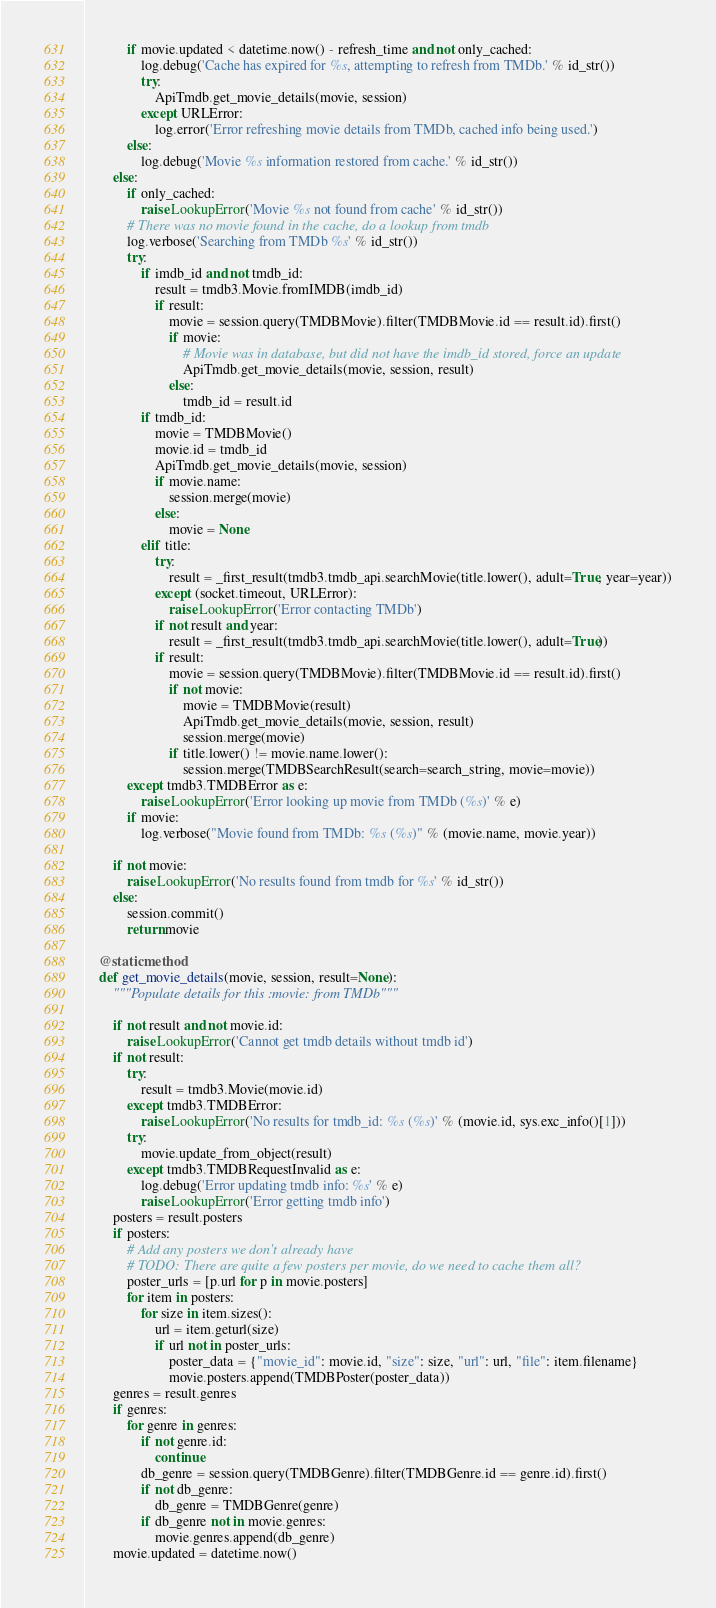<code> <loc_0><loc_0><loc_500><loc_500><_Python_>            if movie.updated < datetime.now() - refresh_time and not only_cached:
                log.debug('Cache has expired for %s, attempting to refresh from TMDb.' % id_str())
                try:
                    ApiTmdb.get_movie_details(movie, session)
                except URLError:
                    log.error('Error refreshing movie details from TMDb, cached info being used.')
            else:
                log.debug('Movie %s information restored from cache.' % id_str())
        else:
            if only_cached:
                raise LookupError('Movie %s not found from cache' % id_str())
            # There was no movie found in the cache, do a lookup from tmdb
            log.verbose('Searching from TMDb %s' % id_str())
            try:
                if imdb_id and not tmdb_id:
                    result = tmdb3.Movie.fromIMDB(imdb_id)
                    if result:
                        movie = session.query(TMDBMovie).filter(TMDBMovie.id == result.id).first()
                        if movie:
                            # Movie was in database, but did not have the imdb_id stored, force an update
                            ApiTmdb.get_movie_details(movie, session, result)
                        else:
                            tmdb_id = result.id
                if tmdb_id:
                    movie = TMDBMovie()
                    movie.id = tmdb_id
                    ApiTmdb.get_movie_details(movie, session)
                    if movie.name:
                        session.merge(movie)
                    else:
                        movie = None
                elif title:
                    try:
                        result = _first_result(tmdb3.tmdb_api.searchMovie(title.lower(), adult=True, year=year))
                    except (socket.timeout, URLError):
                        raise LookupError('Error contacting TMDb')
                    if not result and year:
                        result = _first_result(tmdb3.tmdb_api.searchMovie(title.lower(), adult=True))
                    if result:
                        movie = session.query(TMDBMovie).filter(TMDBMovie.id == result.id).first()
                        if not movie:
                            movie = TMDBMovie(result)
                            ApiTmdb.get_movie_details(movie, session, result)
                            session.merge(movie)
                        if title.lower() != movie.name.lower():
                            session.merge(TMDBSearchResult(search=search_string, movie=movie))
            except tmdb3.TMDBError as e:
                raise LookupError('Error looking up movie from TMDb (%s)' % e)
            if movie:
                log.verbose("Movie found from TMDb: %s (%s)" % (movie.name, movie.year))

        if not movie:
            raise LookupError('No results found from tmdb for %s' % id_str())
        else:
            session.commit()
            return movie

    @staticmethod
    def get_movie_details(movie, session, result=None):
        """Populate details for this :movie: from TMDb"""

        if not result and not movie.id:
            raise LookupError('Cannot get tmdb details without tmdb id')
        if not result:
            try:
                result = tmdb3.Movie(movie.id)
            except tmdb3.TMDBError:
                raise LookupError('No results for tmdb_id: %s (%s)' % (movie.id, sys.exc_info()[1]))
            try:
                movie.update_from_object(result)
            except tmdb3.TMDBRequestInvalid as e:
                log.debug('Error updating tmdb info: %s' % e)
                raise LookupError('Error getting tmdb info')
        posters = result.posters
        if posters:
            # Add any posters we don't already have
            # TODO: There are quite a few posters per movie, do we need to cache them all?
            poster_urls = [p.url for p in movie.posters]
            for item in posters:
                for size in item.sizes():
                    url = item.geturl(size)
                    if url not in poster_urls:
                        poster_data = {"movie_id": movie.id, "size": size, "url": url, "file": item.filename}
                        movie.posters.append(TMDBPoster(poster_data))
        genres = result.genres
        if genres:
            for genre in genres:
                if not genre.id:
                    continue
                db_genre = session.query(TMDBGenre).filter(TMDBGenre.id == genre.id).first()
                if not db_genre:
                    db_genre = TMDBGenre(genre)
                if db_genre not in movie.genres:
                    movie.genres.append(db_genre)
        movie.updated = datetime.now()

</code> 